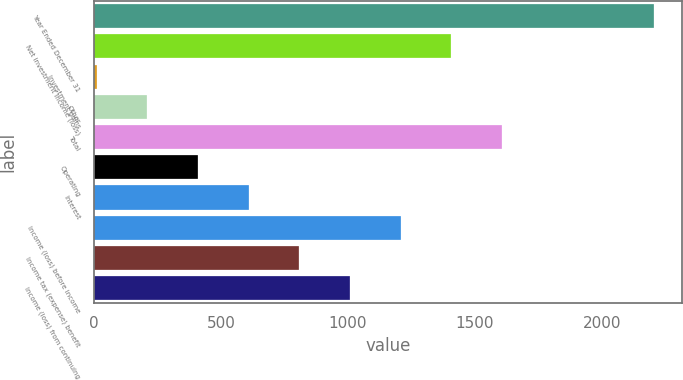Convert chart to OTSL. <chart><loc_0><loc_0><loc_500><loc_500><bar_chart><fcel>Year Ended December 31<fcel>Net investment income (loss)<fcel>Investment gains<fcel>Other<fcel>Total<fcel>Operating<fcel>Interest<fcel>Income (loss) before income<fcel>Income tax (expense) benefit<fcel>Income (loss) from continuing<nl><fcel>2205.6<fcel>1407.2<fcel>10<fcel>209.6<fcel>1606.8<fcel>409.2<fcel>608.8<fcel>1207.6<fcel>808.4<fcel>1008<nl></chart> 